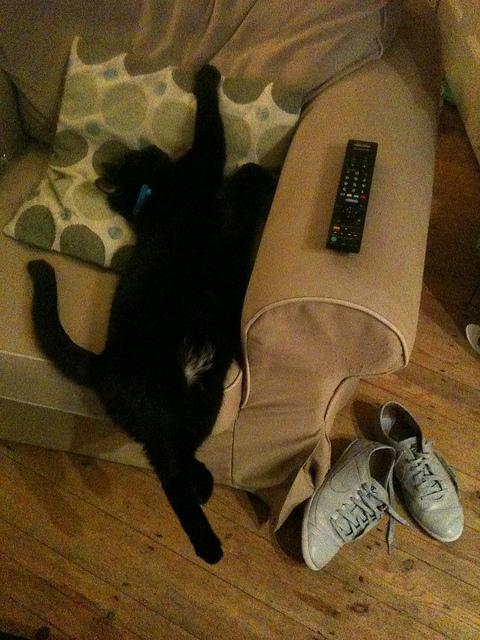What brand are the shoes on the ground? Please explain your reasoning. nike. The swoosh logo on the shoes belong to the company listed in option a. 